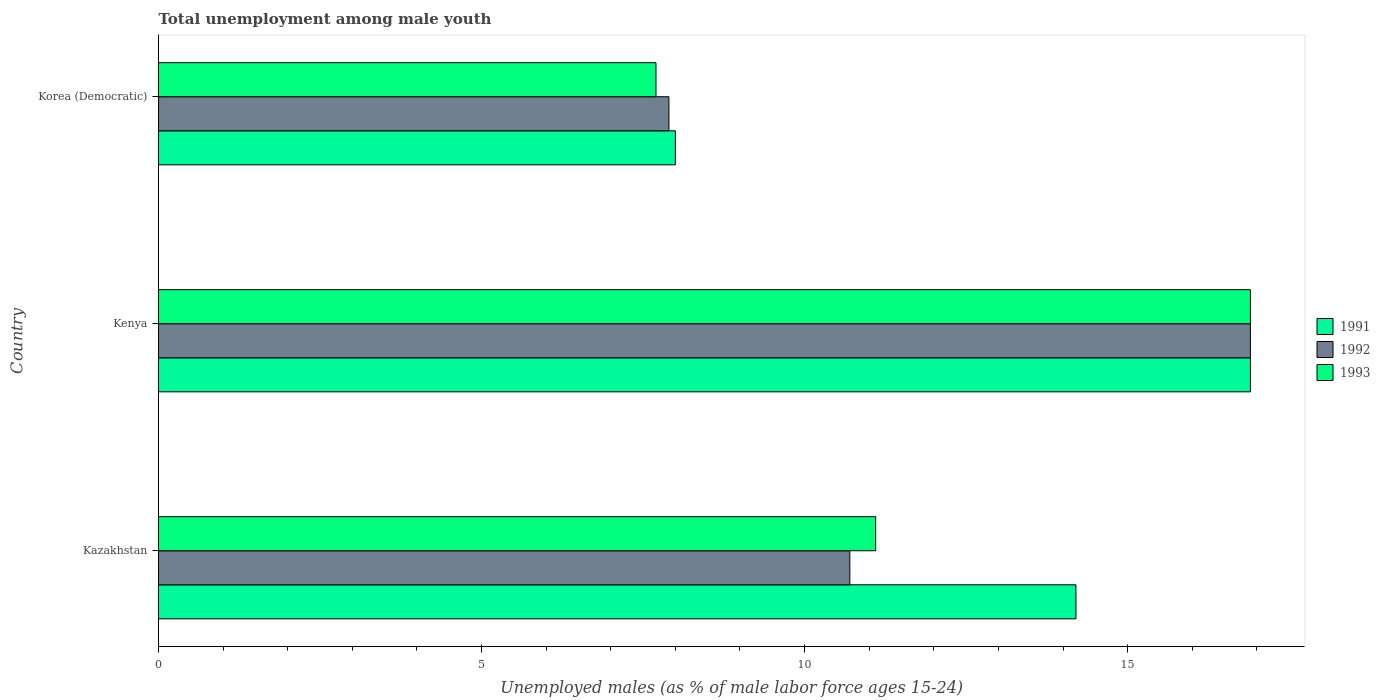How many groups of bars are there?
Provide a short and direct response. 3. Are the number of bars on each tick of the Y-axis equal?
Give a very brief answer. Yes. How many bars are there on the 3rd tick from the top?
Provide a succinct answer. 3. What is the label of the 3rd group of bars from the top?
Offer a very short reply. Kazakhstan. What is the percentage of unemployed males in in 1992 in Kenya?
Your answer should be compact. 16.9. Across all countries, what is the maximum percentage of unemployed males in in 1991?
Your answer should be compact. 16.9. Across all countries, what is the minimum percentage of unemployed males in in 1992?
Your response must be concise. 7.9. In which country was the percentage of unemployed males in in 1993 maximum?
Your answer should be compact. Kenya. In which country was the percentage of unemployed males in in 1991 minimum?
Your response must be concise. Korea (Democratic). What is the total percentage of unemployed males in in 1993 in the graph?
Make the answer very short. 35.7. What is the difference between the percentage of unemployed males in in 1992 in Kenya and that in Korea (Democratic)?
Give a very brief answer. 9. What is the difference between the percentage of unemployed males in in 1991 in Kazakhstan and the percentage of unemployed males in in 1992 in Kenya?
Provide a short and direct response. -2.7. What is the average percentage of unemployed males in in 1993 per country?
Offer a very short reply. 11.9. What is the difference between the percentage of unemployed males in in 1993 and percentage of unemployed males in in 1992 in Korea (Democratic)?
Keep it short and to the point. -0.2. What is the ratio of the percentage of unemployed males in in 1991 in Kazakhstan to that in Kenya?
Your answer should be compact. 0.84. Is the percentage of unemployed males in in 1991 in Kazakhstan less than that in Korea (Democratic)?
Provide a succinct answer. No. Is the difference between the percentage of unemployed males in in 1993 in Kazakhstan and Kenya greater than the difference between the percentage of unemployed males in in 1992 in Kazakhstan and Kenya?
Give a very brief answer. Yes. What is the difference between the highest and the second highest percentage of unemployed males in in 1991?
Provide a short and direct response. 2.7. What is the difference between the highest and the lowest percentage of unemployed males in in 1991?
Give a very brief answer. 8.9. In how many countries, is the percentage of unemployed males in in 1991 greater than the average percentage of unemployed males in in 1991 taken over all countries?
Make the answer very short. 2. Is the sum of the percentage of unemployed males in in 1992 in Kazakhstan and Korea (Democratic) greater than the maximum percentage of unemployed males in in 1991 across all countries?
Keep it short and to the point. Yes. What does the 1st bar from the top in Kazakhstan represents?
Offer a terse response. 1993. What does the 3rd bar from the bottom in Korea (Democratic) represents?
Provide a succinct answer. 1993. Is it the case that in every country, the sum of the percentage of unemployed males in in 1993 and percentage of unemployed males in in 1991 is greater than the percentage of unemployed males in in 1992?
Offer a terse response. Yes. How many bars are there?
Give a very brief answer. 9. Where does the legend appear in the graph?
Provide a succinct answer. Center right. How many legend labels are there?
Offer a terse response. 3. What is the title of the graph?
Keep it short and to the point. Total unemployment among male youth. What is the label or title of the X-axis?
Provide a succinct answer. Unemployed males (as % of male labor force ages 15-24). What is the label or title of the Y-axis?
Offer a very short reply. Country. What is the Unemployed males (as % of male labor force ages 15-24) in 1991 in Kazakhstan?
Provide a short and direct response. 14.2. What is the Unemployed males (as % of male labor force ages 15-24) of 1992 in Kazakhstan?
Provide a short and direct response. 10.7. What is the Unemployed males (as % of male labor force ages 15-24) of 1993 in Kazakhstan?
Make the answer very short. 11.1. What is the Unemployed males (as % of male labor force ages 15-24) in 1991 in Kenya?
Ensure brevity in your answer.  16.9. What is the Unemployed males (as % of male labor force ages 15-24) of 1992 in Kenya?
Your answer should be very brief. 16.9. What is the Unemployed males (as % of male labor force ages 15-24) of 1993 in Kenya?
Keep it short and to the point. 16.9. What is the Unemployed males (as % of male labor force ages 15-24) of 1992 in Korea (Democratic)?
Provide a succinct answer. 7.9. What is the Unemployed males (as % of male labor force ages 15-24) in 1993 in Korea (Democratic)?
Provide a short and direct response. 7.7. Across all countries, what is the maximum Unemployed males (as % of male labor force ages 15-24) of 1991?
Your answer should be very brief. 16.9. Across all countries, what is the maximum Unemployed males (as % of male labor force ages 15-24) of 1992?
Give a very brief answer. 16.9. Across all countries, what is the maximum Unemployed males (as % of male labor force ages 15-24) of 1993?
Ensure brevity in your answer.  16.9. Across all countries, what is the minimum Unemployed males (as % of male labor force ages 15-24) of 1991?
Give a very brief answer. 8. Across all countries, what is the minimum Unemployed males (as % of male labor force ages 15-24) in 1992?
Offer a very short reply. 7.9. Across all countries, what is the minimum Unemployed males (as % of male labor force ages 15-24) of 1993?
Ensure brevity in your answer.  7.7. What is the total Unemployed males (as % of male labor force ages 15-24) of 1991 in the graph?
Give a very brief answer. 39.1. What is the total Unemployed males (as % of male labor force ages 15-24) of 1992 in the graph?
Make the answer very short. 35.5. What is the total Unemployed males (as % of male labor force ages 15-24) of 1993 in the graph?
Offer a terse response. 35.7. What is the difference between the Unemployed males (as % of male labor force ages 15-24) of 1993 in Kazakhstan and that in Kenya?
Ensure brevity in your answer.  -5.8. What is the difference between the Unemployed males (as % of male labor force ages 15-24) in 1993 in Kazakhstan and that in Korea (Democratic)?
Provide a short and direct response. 3.4. What is the difference between the Unemployed males (as % of male labor force ages 15-24) in 1992 in Kenya and that in Korea (Democratic)?
Provide a short and direct response. 9. What is the difference between the Unemployed males (as % of male labor force ages 15-24) in 1992 in Kazakhstan and the Unemployed males (as % of male labor force ages 15-24) in 1993 in Kenya?
Provide a short and direct response. -6.2. What is the difference between the Unemployed males (as % of male labor force ages 15-24) of 1992 in Kazakhstan and the Unemployed males (as % of male labor force ages 15-24) of 1993 in Korea (Democratic)?
Your response must be concise. 3. What is the difference between the Unemployed males (as % of male labor force ages 15-24) in 1991 in Kenya and the Unemployed males (as % of male labor force ages 15-24) in 1992 in Korea (Democratic)?
Provide a succinct answer. 9. What is the difference between the Unemployed males (as % of male labor force ages 15-24) in 1992 in Kenya and the Unemployed males (as % of male labor force ages 15-24) in 1993 in Korea (Democratic)?
Keep it short and to the point. 9.2. What is the average Unemployed males (as % of male labor force ages 15-24) of 1991 per country?
Make the answer very short. 13.03. What is the average Unemployed males (as % of male labor force ages 15-24) of 1992 per country?
Keep it short and to the point. 11.83. What is the difference between the Unemployed males (as % of male labor force ages 15-24) of 1991 and Unemployed males (as % of male labor force ages 15-24) of 1993 in Kazakhstan?
Your answer should be compact. 3.1. What is the difference between the Unemployed males (as % of male labor force ages 15-24) of 1991 and Unemployed males (as % of male labor force ages 15-24) of 1992 in Kenya?
Offer a terse response. 0. What is the difference between the Unemployed males (as % of male labor force ages 15-24) of 1992 and Unemployed males (as % of male labor force ages 15-24) of 1993 in Korea (Democratic)?
Offer a terse response. 0.2. What is the ratio of the Unemployed males (as % of male labor force ages 15-24) in 1991 in Kazakhstan to that in Kenya?
Offer a terse response. 0.84. What is the ratio of the Unemployed males (as % of male labor force ages 15-24) in 1992 in Kazakhstan to that in Kenya?
Your answer should be very brief. 0.63. What is the ratio of the Unemployed males (as % of male labor force ages 15-24) in 1993 in Kazakhstan to that in Kenya?
Give a very brief answer. 0.66. What is the ratio of the Unemployed males (as % of male labor force ages 15-24) in 1991 in Kazakhstan to that in Korea (Democratic)?
Your response must be concise. 1.77. What is the ratio of the Unemployed males (as % of male labor force ages 15-24) of 1992 in Kazakhstan to that in Korea (Democratic)?
Offer a very short reply. 1.35. What is the ratio of the Unemployed males (as % of male labor force ages 15-24) of 1993 in Kazakhstan to that in Korea (Democratic)?
Offer a terse response. 1.44. What is the ratio of the Unemployed males (as % of male labor force ages 15-24) in 1991 in Kenya to that in Korea (Democratic)?
Make the answer very short. 2.11. What is the ratio of the Unemployed males (as % of male labor force ages 15-24) in 1992 in Kenya to that in Korea (Democratic)?
Your answer should be compact. 2.14. What is the ratio of the Unemployed males (as % of male labor force ages 15-24) of 1993 in Kenya to that in Korea (Democratic)?
Your response must be concise. 2.19. What is the difference between the highest and the second highest Unemployed males (as % of male labor force ages 15-24) in 1991?
Provide a short and direct response. 2.7. What is the difference between the highest and the second highest Unemployed males (as % of male labor force ages 15-24) of 1992?
Your response must be concise. 6.2. What is the difference between the highest and the lowest Unemployed males (as % of male labor force ages 15-24) in 1991?
Offer a very short reply. 8.9. 